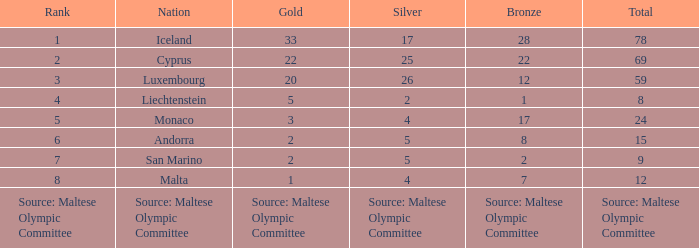What rank is the nation with 2 silver medals? 4.0. 